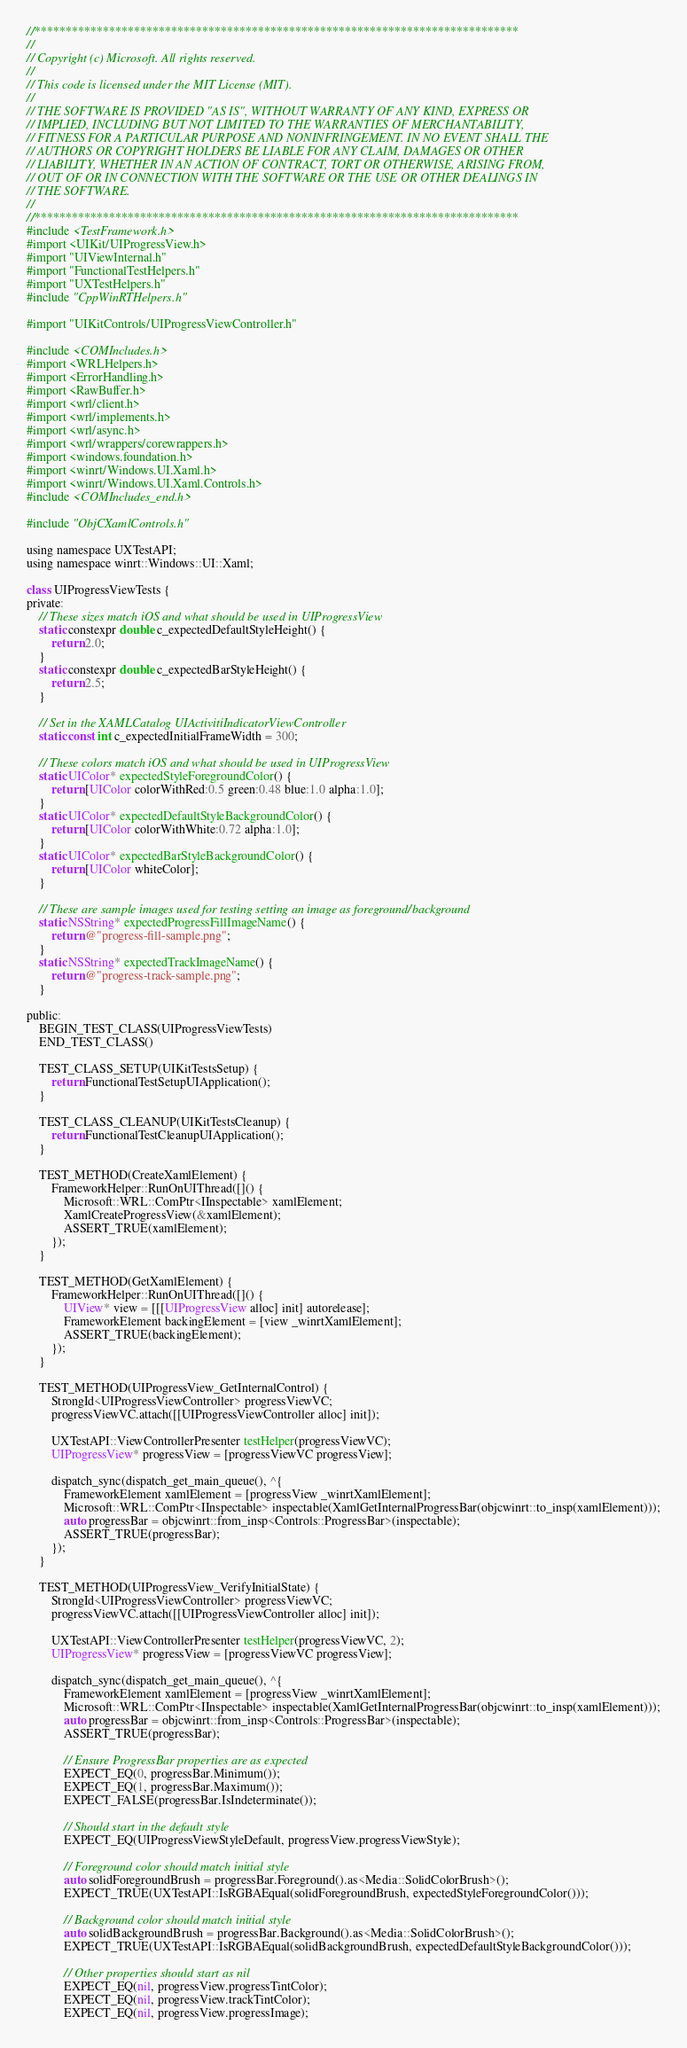<code> <loc_0><loc_0><loc_500><loc_500><_ObjectiveC_>//******************************************************************************
//
// Copyright (c) Microsoft. All rights reserved.
//
// This code is licensed under the MIT License (MIT).
//
// THE SOFTWARE IS PROVIDED "AS IS", WITHOUT WARRANTY OF ANY KIND, EXPRESS OR
// IMPLIED, INCLUDING BUT NOT LIMITED TO THE WARRANTIES OF MERCHANTABILITY,
// FITNESS FOR A PARTICULAR PURPOSE AND NONINFRINGEMENT. IN NO EVENT SHALL THE
// AUTHORS OR COPYRIGHT HOLDERS BE LIABLE FOR ANY CLAIM, DAMAGES OR OTHER
// LIABILITY, WHETHER IN AN ACTION OF CONTRACT, TORT OR OTHERWISE, ARISING FROM,
// OUT OF OR IN CONNECTION WITH THE SOFTWARE OR THE USE OR OTHER DEALINGS IN
// THE SOFTWARE.
//
//******************************************************************************
#include <TestFramework.h>
#import <UIKit/UIProgressView.h>
#import "UIViewInternal.h"
#import "FunctionalTestHelpers.h"
#import "UXTestHelpers.h"
#include "CppWinRTHelpers.h"

#import "UIKitControls/UIProgressViewController.h"

#include <COMIncludes.h>
#import <WRLHelpers.h>
#import <ErrorHandling.h>
#import <RawBuffer.h>
#import <wrl/client.h>
#import <wrl/implements.h>
#import <wrl/async.h>
#import <wrl/wrappers/corewrappers.h>
#import <windows.foundation.h>
#import <winrt/Windows.UI.Xaml.h>
#import <winrt/Windows.UI.Xaml.Controls.h>
#include <COMIncludes_end.h>

#include "ObjCXamlControls.h"

using namespace UXTestAPI;
using namespace winrt::Windows::UI::Xaml;

class UIProgressViewTests {
private:
    // These sizes match iOS and what should be used in UIProgressView
    static constexpr double c_expectedDefaultStyleHeight() {
        return 2.0;
    }
    static constexpr double c_expectedBarStyleHeight() {
        return 2.5;
    }

    // Set in the XAMLCatalog UIActivitiIndicatorViewController
    static const int c_expectedInitialFrameWidth = 300;

    // These colors match iOS and what should be used in UIProgressView
    static UIColor* expectedStyleForegroundColor() {
        return [UIColor colorWithRed:0.5 green:0.48 blue:1.0 alpha:1.0];
    }
    static UIColor* expectedDefaultStyleBackgroundColor() {
        return [UIColor colorWithWhite:0.72 alpha:1.0];
    }
    static UIColor* expectedBarStyleBackgroundColor() {
        return [UIColor whiteColor];
    }

    // These are sample images used for testing setting an image as foreground/background
    static NSString* expectedProgressFillImageName() {
        return @"progress-fill-sample.png";
    }
    static NSString* expectedTrackImageName() {
        return @"progress-track-sample.png";
    }

public:
    BEGIN_TEST_CLASS(UIProgressViewTests)
    END_TEST_CLASS()

    TEST_CLASS_SETUP(UIKitTestsSetup) {
        return FunctionalTestSetupUIApplication();
    }

    TEST_CLASS_CLEANUP(UIKitTestsCleanup) {
        return FunctionalTestCleanupUIApplication();
    }

    TEST_METHOD(CreateXamlElement) {
        FrameworkHelper::RunOnUIThread([]() {
            Microsoft::WRL::ComPtr<IInspectable> xamlElement;
            XamlCreateProgressView(&xamlElement);
            ASSERT_TRUE(xamlElement);
        });
    }

    TEST_METHOD(GetXamlElement) {
        FrameworkHelper::RunOnUIThread([]() {
            UIView* view = [[[UIProgressView alloc] init] autorelease];
            FrameworkElement backingElement = [view _winrtXamlElement];
            ASSERT_TRUE(backingElement);
        });
    }

    TEST_METHOD(UIProgressView_GetInternalControl) {
        StrongId<UIProgressViewController> progressViewVC;
        progressViewVC.attach([[UIProgressViewController alloc] init]);

        UXTestAPI::ViewControllerPresenter testHelper(progressViewVC);
        UIProgressView* progressView = [progressViewVC progressView];

        dispatch_sync(dispatch_get_main_queue(), ^{
            FrameworkElement xamlElement = [progressView _winrtXamlElement];
            Microsoft::WRL::ComPtr<IInspectable> inspectable(XamlGetInternalProgressBar(objcwinrt::to_insp(xamlElement)));
            auto progressBar = objcwinrt::from_insp<Controls::ProgressBar>(inspectable);
            ASSERT_TRUE(progressBar);
        });
    }

    TEST_METHOD(UIProgressView_VerifyInitialState) {
        StrongId<UIProgressViewController> progressViewVC;
        progressViewVC.attach([[UIProgressViewController alloc] init]);

        UXTestAPI::ViewControllerPresenter testHelper(progressViewVC, 2);
        UIProgressView* progressView = [progressViewVC progressView];

        dispatch_sync(dispatch_get_main_queue(), ^{
            FrameworkElement xamlElement = [progressView _winrtXamlElement];
            Microsoft::WRL::ComPtr<IInspectable> inspectable(XamlGetInternalProgressBar(objcwinrt::to_insp(xamlElement)));
            auto progressBar = objcwinrt::from_insp<Controls::ProgressBar>(inspectable);
            ASSERT_TRUE(progressBar);

            // Ensure ProgressBar properties are as expected
            EXPECT_EQ(0, progressBar.Minimum());
            EXPECT_EQ(1, progressBar.Maximum());
            EXPECT_FALSE(progressBar.IsIndeterminate());

            // Should start in the default style
            EXPECT_EQ(UIProgressViewStyleDefault, progressView.progressViewStyle);

            // Foreground color should match initial style
            auto solidForegroundBrush = progressBar.Foreground().as<Media::SolidColorBrush>();
            EXPECT_TRUE(UXTestAPI::IsRGBAEqual(solidForegroundBrush, expectedStyleForegroundColor()));

            // Background color should match initial style
            auto solidBackgroundBrush = progressBar.Background().as<Media::SolidColorBrush>();
            EXPECT_TRUE(UXTestAPI::IsRGBAEqual(solidBackgroundBrush, expectedDefaultStyleBackgroundColor()));

            // Other properties should start as nil
            EXPECT_EQ(nil, progressView.progressTintColor);
            EXPECT_EQ(nil, progressView.trackTintColor);
            EXPECT_EQ(nil, progressView.progressImage);</code> 